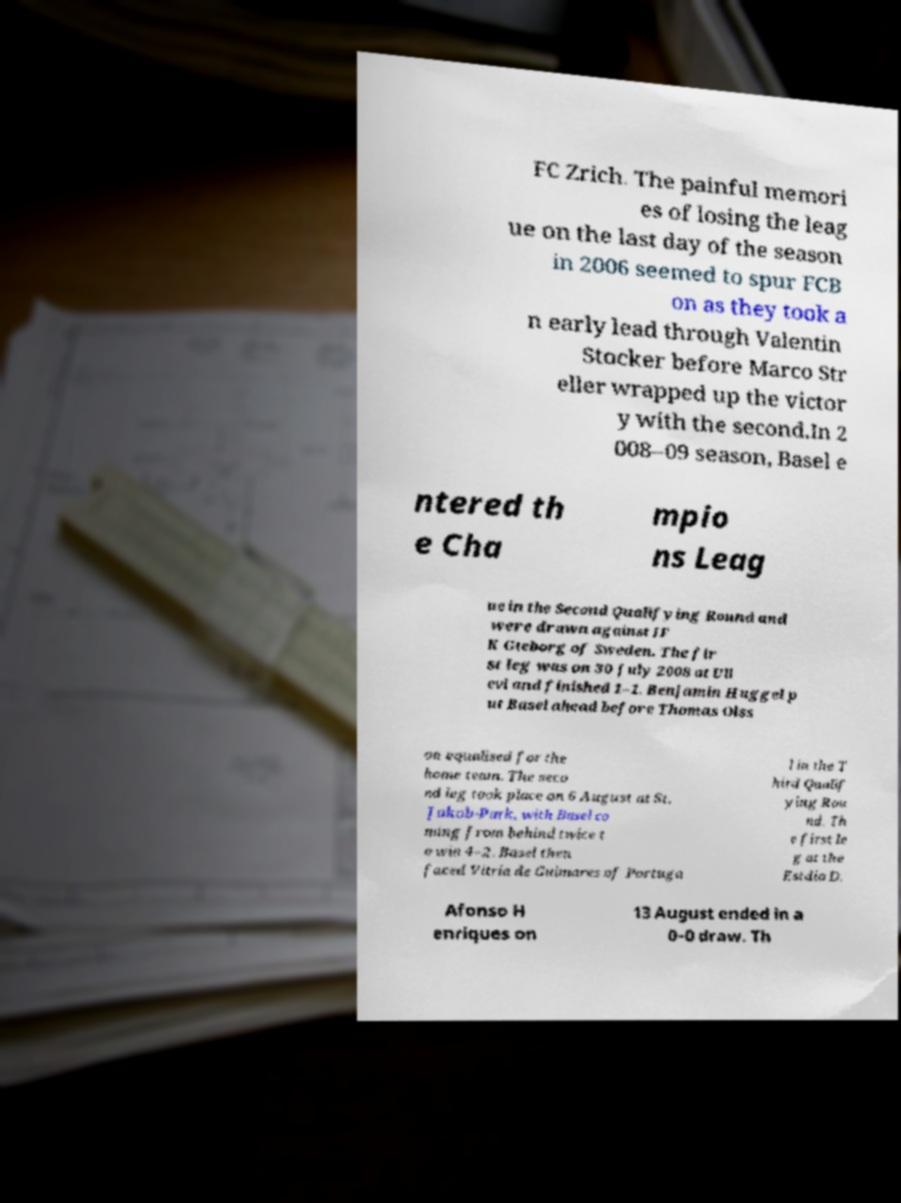There's text embedded in this image that I need extracted. Can you transcribe it verbatim? FC Zrich. The painful memori es of losing the leag ue on the last day of the season in 2006 seemed to spur FCB on as they took a n early lead through Valentin Stocker before Marco Str eller wrapped up the victor y with the second.In 2 008–09 season, Basel e ntered th e Cha mpio ns Leag ue in the Second Qualifying Round and were drawn against IF K Gteborg of Sweden. The fir st leg was on 30 July 2008 at Ull evi and finished 1–1. Benjamin Huggel p ut Basel ahead before Thomas Olss on equalised for the home team. The seco nd leg took place on 6 August at St. Jakob-Park, with Basel co ming from behind twice t o win 4–2. Basel then faced Vitria de Guimares of Portuga l in the T hird Qualif ying Rou nd. Th e first le g at the Estdio D. Afonso H enriques on 13 August ended in a 0–0 draw. Th 